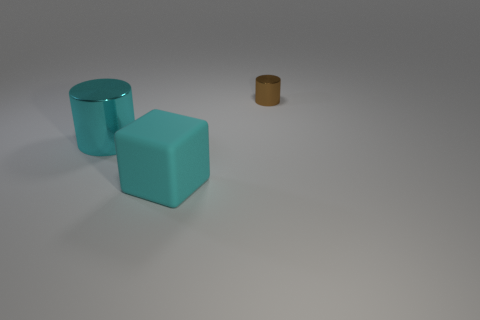How many other things are the same color as the rubber block?
Offer a very short reply. 1. How many brown shiny things are there?
Offer a very short reply. 1. Is the number of metal objects on the left side of the tiny shiny cylinder less than the number of small cyan matte balls?
Give a very brief answer. No. Is the material of the cylinder right of the large cyan metal cylinder the same as the large cyan cube?
Give a very brief answer. No. There is a metallic thing that is in front of the metallic object behind the big cyan object that is behind the matte cube; what shape is it?
Make the answer very short. Cylinder. Is there a red matte sphere that has the same size as the rubber thing?
Your answer should be very brief. No. What size is the matte object?
Ensure brevity in your answer.  Large. What number of other cyan objects are the same size as the cyan shiny object?
Ensure brevity in your answer.  1. Is the number of large metallic objects on the right side of the large shiny object less than the number of big cyan objects that are on the left side of the cyan matte thing?
Make the answer very short. Yes. There is a cylinder behind the big metal cylinder that is on the left side of the rubber thing in front of the large cyan metal thing; what is its size?
Make the answer very short. Small. 